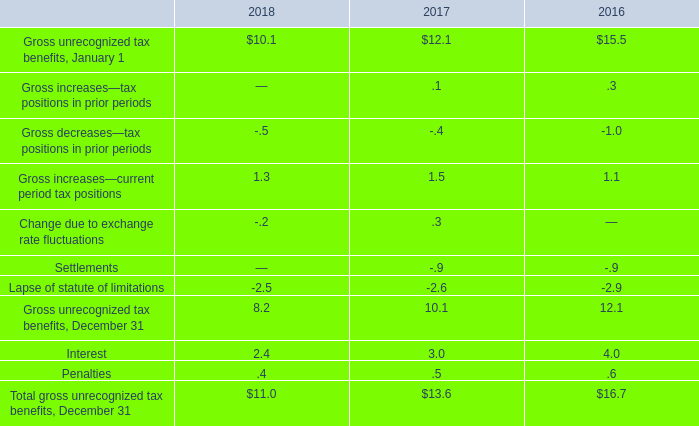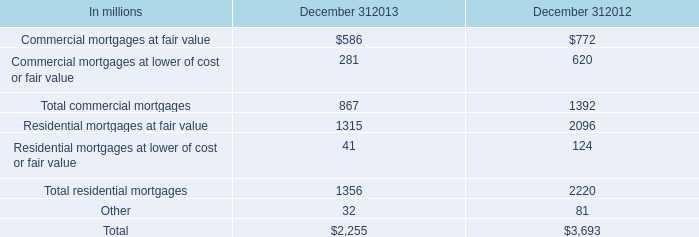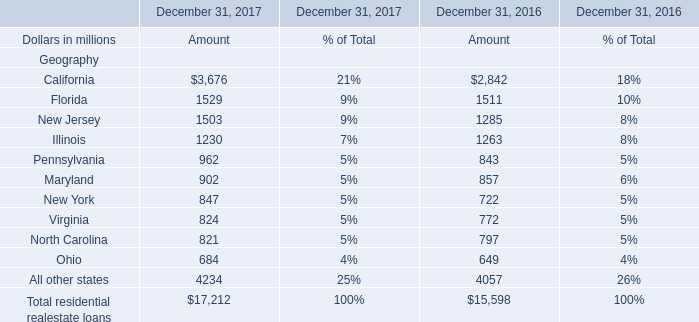Which year is the Amount of residential realestate loans on December 31 in terms of Illinois lower? 
Answer: 2017. 